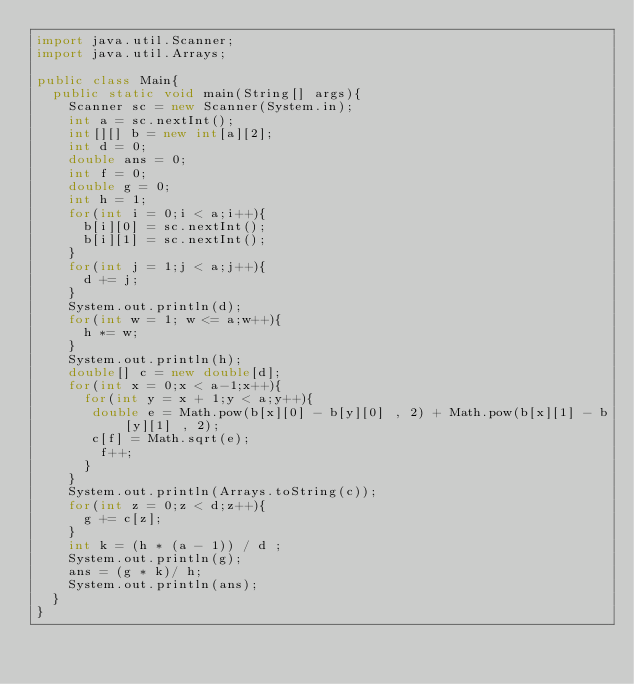<code> <loc_0><loc_0><loc_500><loc_500><_Java_>import java.util.Scanner;
import java.util.Arrays;

public class Main{
  public static void main(String[] args){
    Scanner sc = new Scanner(System.in);
    int a = sc.nextInt();
    int[][] b = new int[a][2];
    int d = 0;
    double ans = 0;
    int f = 0;
    double g = 0;  
    int h = 1;
    for(int i = 0;i < a;i++){
      b[i][0] = sc.nextInt();
      b[i][1] = sc.nextInt();      
    }
    for(int j = 1;j < a;j++){
      d += j;
    }
    System.out.println(d);    
    for(int w = 1; w <= a;w++){
      h *= w;
    }
    System.out.println(h);
    double[] c = new double[d];
    for(int x = 0;x < a-1;x++){
      for(int y = x + 1;y < a;y++){
       double e = Math.pow(b[x][0] - b[y][0] , 2) + Math.pow(b[x][1] - b[y][1] , 2);
       c[f] = Math.sqrt(e);
        f++;
      }
    }
    System.out.println(Arrays.toString(c));
    for(int z = 0;z < d;z++){
      g += c[z]; 
    }
    int k = (h * (a - 1)) / d ;
    System.out.println(g);
    ans = (g * k)/ h;
    System.out.println(ans);
  }
}</code> 